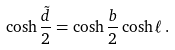<formula> <loc_0><loc_0><loc_500><loc_500>\cosh \frac { \tilde { d } } { 2 } = \cosh \frac { b } { 2 } \cosh \ell \, .</formula> 